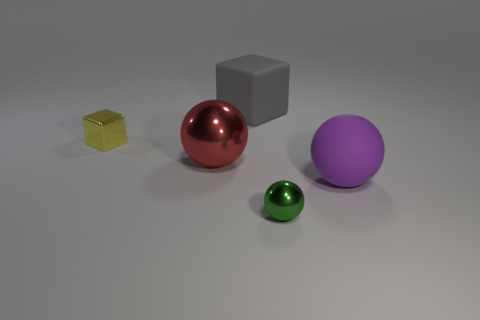There is a purple rubber thing; is its size the same as the sphere that is on the left side of the tiny shiny sphere?
Ensure brevity in your answer.  Yes. How many things are either green rubber objects or big purple rubber spheres?
Your answer should be very brief. 1. Are there any yellow balls made of the same material as the big red ball?
Give a very brief answer. No. What is the color of the rubber thing behind the ball to the left of the tiny green thing?
Your response must be concise. Gray. Does the purple ball have the same size as the yellow metallic thing?
Ensure brevity in your answer.  No. What number of cylinders are large purple matte objects or big cyan metal objects?
Provide a short and direct response. 0. There is a object on the right side of the small green ball; what number of small shiny objects are in front of it?
Your answer should be compact. 1. Does the large purple rubber thing have the same shape as the green metallic thing?
Give a very brief answer. Yes. What is the size of the green metallic object that is the same shape as the big red object?
Your answer should be compact. Small. What is the shape of the large matte thing that is on the right side of the large object behind the tiny yellow object?
Offer a very short reply. Sphere. 